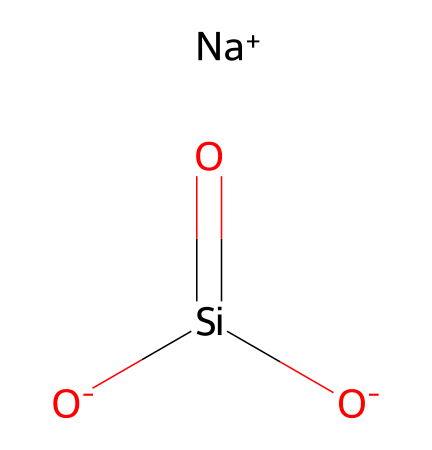What is the cation present in this chemical structure? The chemical structure includes a Sodium ion, which is represented by [Na+]. This indicates the presence of a cation within the compound.
Answer: Sodium How many oxygen atoms are present in the chemical structure? The chemical structure includes three oxygen atoms, as indicated by the [O-] and surrounding context. Count each one for a total of three.
Answer: Three What is the overall charge of the compound represented? The sodium ion has a charge of +1, while there are two negatively charged oxygen ions ([O-]) and one neutral silicon atom. The total charge is balanced, leading to an overall neutral compound.
Answer: Neutral What type of chemical is sodium silicate? Sodium silicate is classified as an electrolyte, due to its ability to dissociate into ions in solution, thus conducting electricity.
Answer: Electrolyte What is the role of silicon in this chemical structure? Silicon in this structure acts as a central atom bonded to oxygen, forming silicate, which is essential in the consolidation properties for stone conservation.
Answer: Central atom How many silicon-oxygen bonds can be observed in the structure? Observing the given structure, there are two silicon-oxygen double bonds and one silicon-oxygen single bond, leading to a total of three bonds.
Answer: Three 